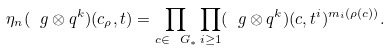Convert formula to latex. <formula><loc_0><loc_0><loc_500><loc_500>\eta _ { n } ( \ g \otimes q ^ { k } ) ( c _ { \rho } , t ) = \prod _ { c \in \ G _ { * } } \prod _ { i \geq 1 } ( \ g \otimes q ^ { k } ) ( c , t ^ { i } ) ^ { m _ { i } ( \rho ( c ) ) } .</formula> 